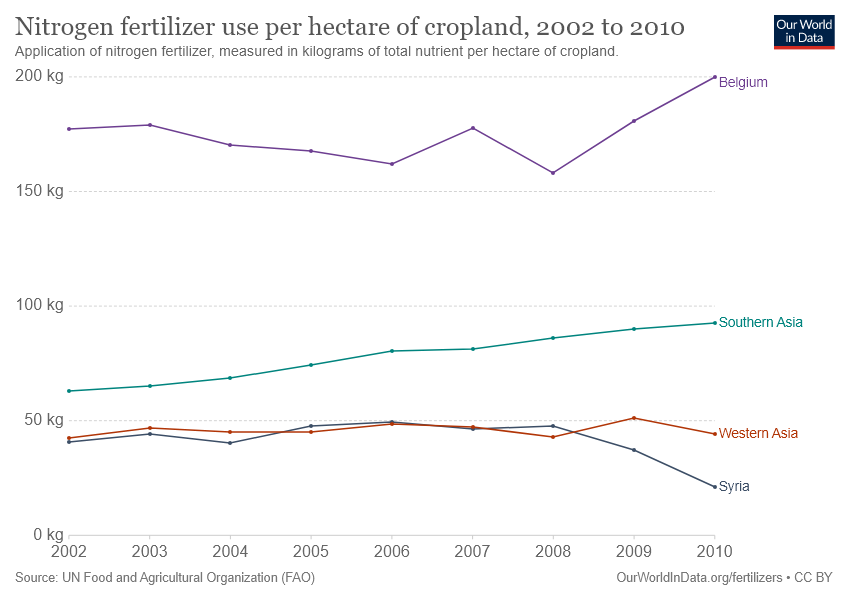Draw attention to some important aspects in this diagram. Western Asia and Syria intersect in the year 2005. The green bar represents Southern Asia. 